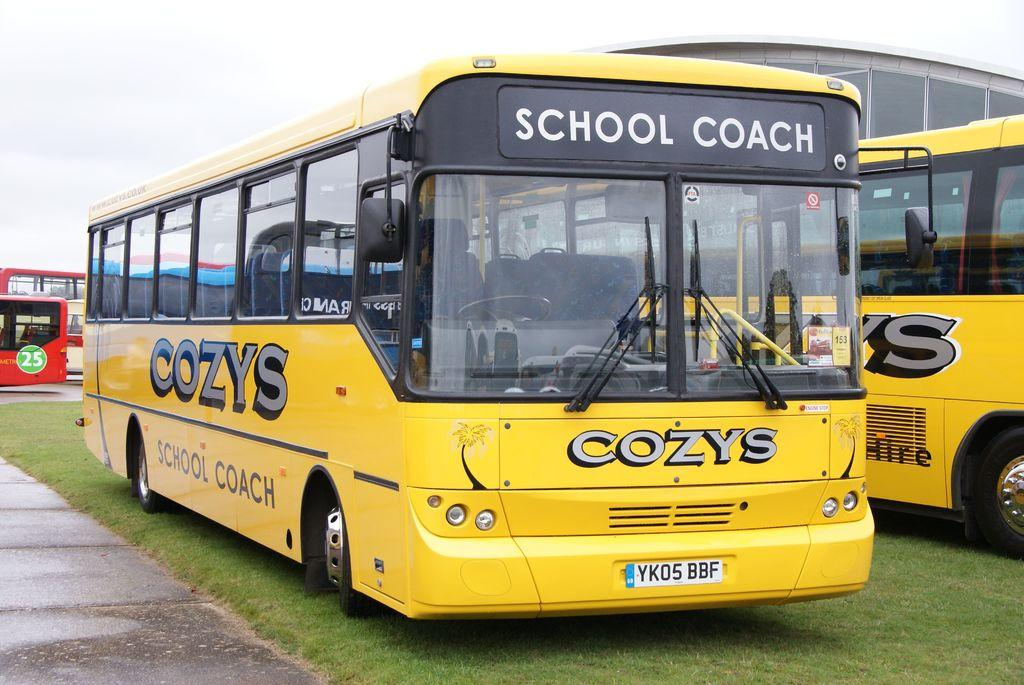What is the main subject in the foreground of the image? There is a school bus in the foreground of the image. Where is the school bus located? The school bus is on a grassy area. What other vehicles can be seen in the image? There is another bus on the right side of the image, and there are buses on the left side of the image. What type of structure is visible on the right side of the image? There is a building on the right side of the image. What is the path of the image used for? The path on the left side of the image is likely used for walking or driving. What is visible at the top of the image? The sky is visible at the top of the image. Where is the sofa located in the image? There is no sofa present in the image. What type of coast can be seen in the image? There is no coast present in the image. 